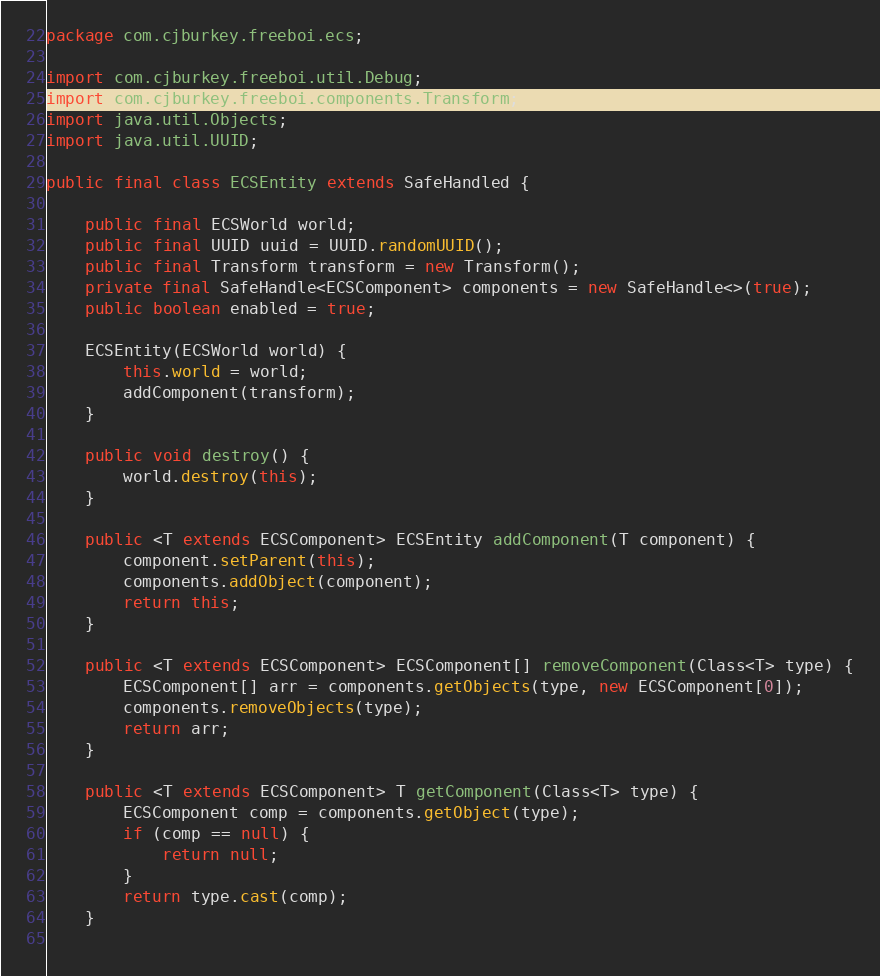<code> <loc_0><loc_0><loc_500><loc_500><_Java_>package com.cjburkey.freeboi.ecs;

import com.cjburkey.freeboi.util.Debug;
import com.cjburkey.freeboi.components.Transform;
import java.util.Objects;
import java.util.UUID;

public final class ECSEntity extends SafeHandled {
    
    public final ECSWorld world;
    public final UUID uuid = UUID.randomUUID();
    public final Transform transform = new Transform();
    private final SafeHandle<ECSComponent> components = new SafeHandle<>(true);
    public boolean enabled = true;
    
    ECSEntity(ECSWorld world) {
        this.world = world;
        addComponent(transform);
    }
    
    public void destroy() {
        world.destroy(this);
    }
    
    public <T extends ECSComponent> ECSEntity addComponent(T component) {
        component.setParent(this);
        components.addObject(component);
        return this;
    }
    
    public <T extends ECSComponent> ECSComponent[] removeComponent(Class<T> type) {
        ECSComponent[] arr = components.getObjects(type, new ECSComponent[0]);
        components.removeObjects(type);
        return arr;
    }
    
    public <T extends ECSComponent> T getComponent(Class<T> type) {
        ECSComponent comp = components.getObject(type);
        if (comp == null) {
            return null;
        }
        return type.cast(comp);
    }
    </code> 